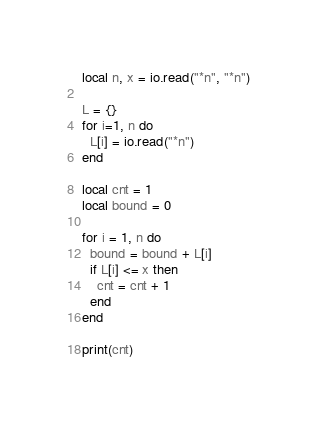<code> <loc_0><loc_0><loc_500><loc_500><_Lua_>local n, x = io.read("*n", "*n")

L = {}
for i=1, n do
  L[i] = io.read("*n")
end

local cnt = 1
local bound = 0

for i = 1, n do
  bound = bound + L[i]
  if L[i] <= x then
    cnt = cnt + 1
  end
end

print(cnt)</code> 